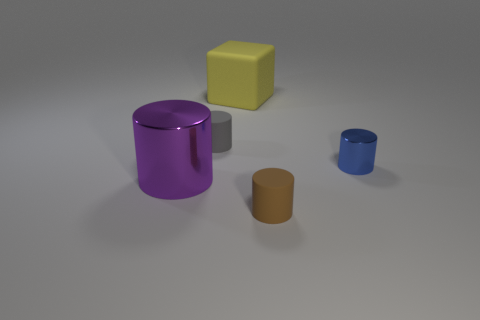Does the big thing that is to the left of the large cube have the same material as the large yellow object?
Give a very brief answer. No. Is the number of gray matte things on the left side of the tiny gray thing the same as the number of large purple cylinders that are behind the large cylinder?
Provide a succinct answer. Yes. There is a rubber cylinder behind the shiny cylinder in front of the blue thing; what is its size?
Keep it short and to the point. Small. There is a tiny cylinder that is both behind the brown rubber thing and on the left side of the blue shiny cylinder; what is it made of?
Ensure brevity in your answer.  Rubber. How many other things are the same size as the brown cylinder?
Provide a short and direct response. 2. The large cylinder has what color?
Offer a very short reply. Purple. Does the small cylinder that is on the left side of the small brown matte cylinder have the same color as the big object that is in front of the big yellow matte thing?
Your answer should be compact. No. What is the size of the yellow rubber block?
Your response must be concise. Large. What size is the metallic thing to the left of the large yellow matte object?
Keep it short and to the point. Large. What shape is the matte object that is behind the blue metal cylinder and right of the small gray matte object?
Offer a terse response. Cube. 